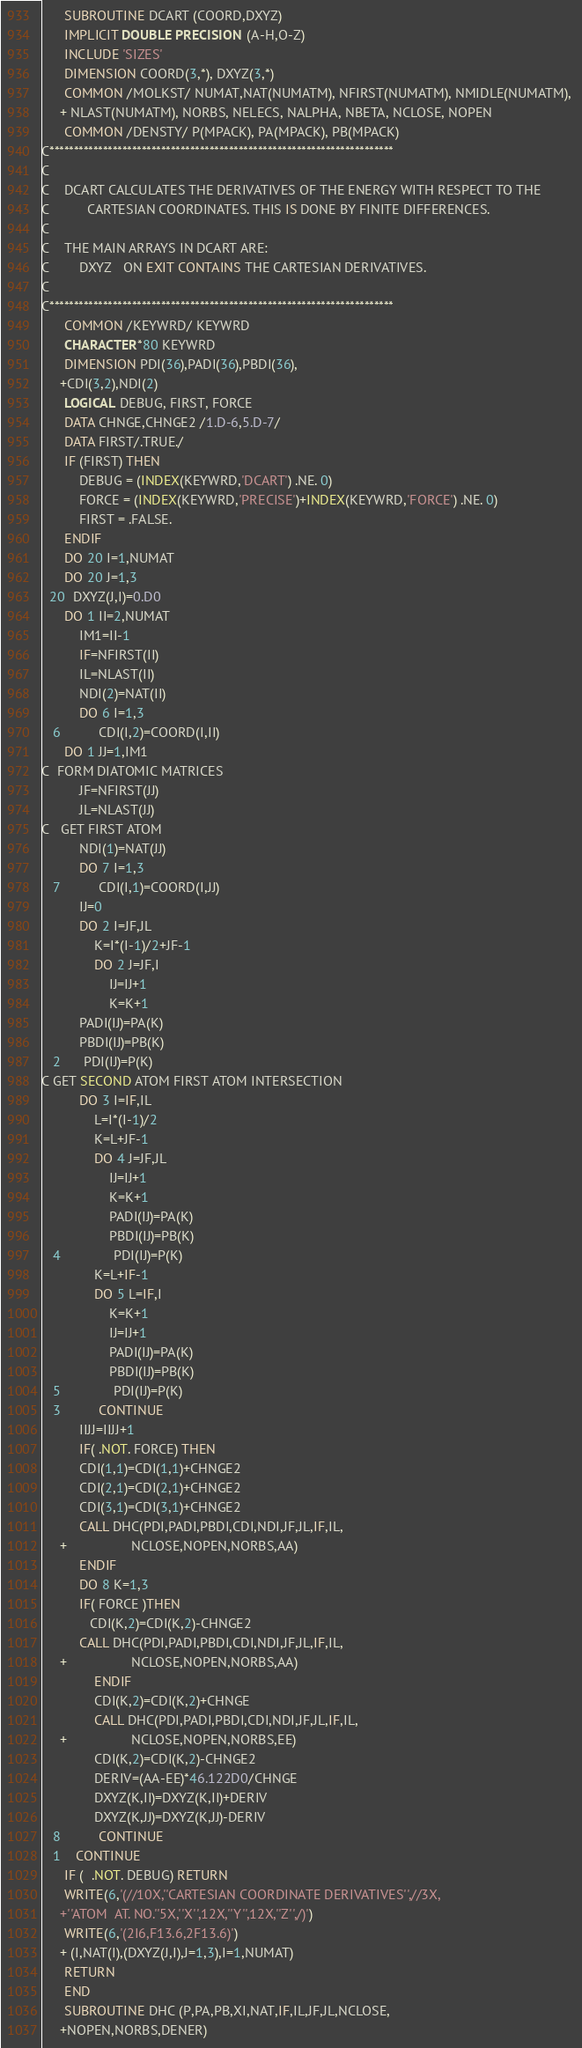Convert code to text. <code><loc_0><loc_0><loc_500><loc_500><_FORTRAN_>      SUBROUTINE DCART (COORD,DXYZ)
      IMPLICIT DOUBLE PRECISION (A-H,O-Z)
      INCLUDE 'SIZES'
      DIMENSION COORD(3,*), DXYZ(3,*)
      COMMON /MOLKST/ NUMAT,NAT(NUMATM), NFIRST(NUMATM), NMIDLE(NUMATM), 
     + NLAST(NUMATM), NORBS, NELECS, NALPHA, NBETA, NCLOSE, NOPEN
      COMMON /DENSTY/ P(MPACK), PA(MPACK), PB(MPACK)
C***********************************************************************
C
C    DCART CALCULATES THE DERIVATIVES OF THE ENERGY WITH RESPECT TO THE
C          CARTESIAN COORDINATES. THIS IS DONE BY FINITE DIFFERENCES.
C
C    THE MAIN ARRAYS IN DCART ARE:
C        DXYZ   ON EXIT CONTAINS THE CARTESIAN DERIVATIVES.
C
C***********************************************************************
      COMMON /KEYWRD/ KEYWRD
      CHARACTER*80 KEYWRD
      DIMENSION PDI(36),PADI(36),PBDI(36),
     +CDI(3,2),NDI(2)
      LOGICAL DEBUG, FIRST, FORCE
      DATA CHNGE,CHNGE2 /1.D-6,5.D-7/
      DATA FIRST/.TRUE./
      IF (FIRST) THEN
          DEBUG = (INDEX(KEYWRD,'DCART') .NE. 0)
          FORCE = (INDEX(KEYWRD,'PRECISE')+INDEX(KEYWRD,'FORCE') .NE. 0)
          FIRST = .FALSE.
      ENDIF
      DO 20 I=1,NUMAT
      DO 20 J=1,3
  20  DXYZ(J,I)=0.D0
      DO 1 II=2,NUMAT
          IM1=II-1
          IF=NFIRST(II)
          IL=NLAST(II)
          NDI(2)=NAT(II)
          DO 6 I=1,3
   6          CDI(I,2)=COORD(I,II)
      DO 1 JJ=1,IM1
C  FORM DIATOMIC MATRICES
          JF=NFIRST(JJ)
          JL=NLAST(JJ)
C   GET FIRST ATOM
          NDI(1)=NAT(JJ)
          DO 7 I=1,3
   7          CDI(I,1)=COORD(I,JJ)
          IJ=0
          DO 2 I=JF,JL
              K=I*(I-1)/2+JF-1
              DO 2 J=JF,I
                  IJ=IJ+1
                  K=K+1
          PADI(IJ)=PA(K)
          PBDI(IJ)=PB(K)
   2      PDI(IJ)=P(K)
C GET SECOND ATOM FIRST ATOM INTERSECTION
          DO 3 I=IF,IL
              L=I*(I-1)/2
              K=L+JF-1
              DO 4 J=JF,JL
                  IJ=IJ+1
                  K=K+1
                  PADI(IJ)=PA(K)
                  PBDI(IJ)=PB(K)
   4              PDI(IJ)=P(K)
              K=L+IF-1
              DO 5 L=IF,I
                  K=K+1
                  IJ=IJ+1
                  PADI(IJ)=PA(K)
                  PBDI(IJ)=PB(K)
   5              PDI(IJ)=P(K)
   3          CONTINUE
          IIJJ=IIJJ+1
          IF( .NOT. FORCE) THEN
          CDI(1,1)=CDI(1,1)+CHNGE2
          CDI(2,1)=CDI(2,1)+CHNGE2
          CDI(3,1)=CDI(3,1)+CHNGE2
          CALL DHC(PDI,PADI,PBDI,CDI,NDI,JF,JL,IF,IL,
     +                 NCLOSE,NOPEN,NORBS,AA)
          ENDIF
          DO 8 K=1,3
          IF( FORCE )THEN
             CDI(K,2)=CDI(K,2)-CHNGE2
          CALL DHC(PDI,PADI,PBDI,CDI,NDI,JF,JL,IF,IL,
     +                 NCLOSE,NOPEN,NORBS,AA)
              ENDIF
              CDI(K,2)=CDI(K,2)+CHNGE
              CALL DHC(PDI,PADI,PBDI,CDI,NDI,JF,JL,IF,IL,
     +                 NCLOSE,NOPEN,NORBS,EE)
              CDI(K,2)=CDI(K,2)-CHNGE2
              DERIV=(AA-EE)*46.122D0/CHNGE
              DXYZ(K,II)=DXYZ(K,II)+DERIV
              DXYZ(K,JJ)=DXYZ(K,JJ)-DERIV
   8          CONTINUE
   1    CONTINUE
      IF (  .NOT. DEBUG) RETURN
      WRITE(6,'(//10X,''CARTESIAN COORDINATE DERIVATIVES'',//3X,
     +''ATOM  AT. NO.''5X,''X'',12X,''Y'',12X,''Z'',/)')
      WRITE(6,'(2I6,F13.6,2F13.6)')
     + (I,NAT(I),(DXYZ(J,I),J=1,3),I=1,NUMAT)
      RETURN
      END
      SUBROUTINE DHC (P,PA,PB,XI,NAT,IF,IL,JF,JL,NCLOSE,
     +NOPEN,NORBS,DENER)</code> 